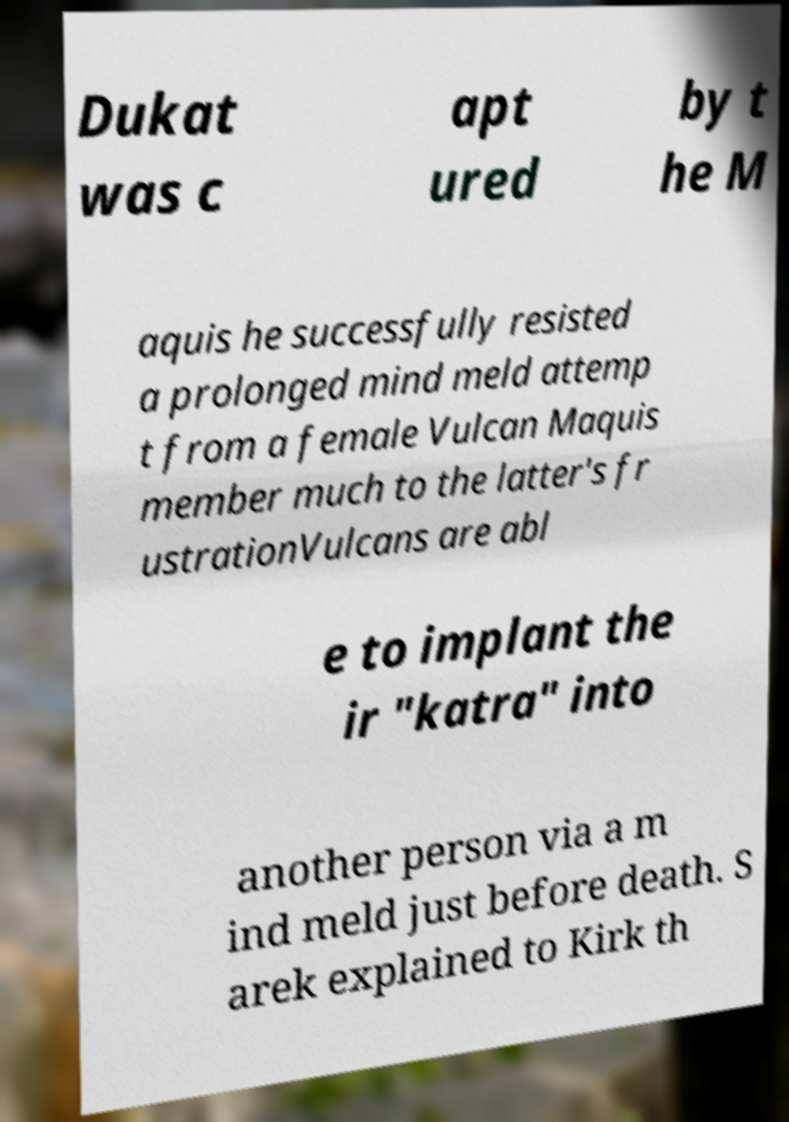Can you read and provide the text displayed in the image?This photo seems to have some interesting text. Can you extract and type it out for me? Dukat was c apt ured by t he M aquis he successfully resisted a prolonged mind meld attemp t from a female Vulcan Maquis member much to the latter's fr ustrationVulcans are abl e to implant the ir "katra" into another person via a m ind meld just before death. S arek explained to Kirk th 